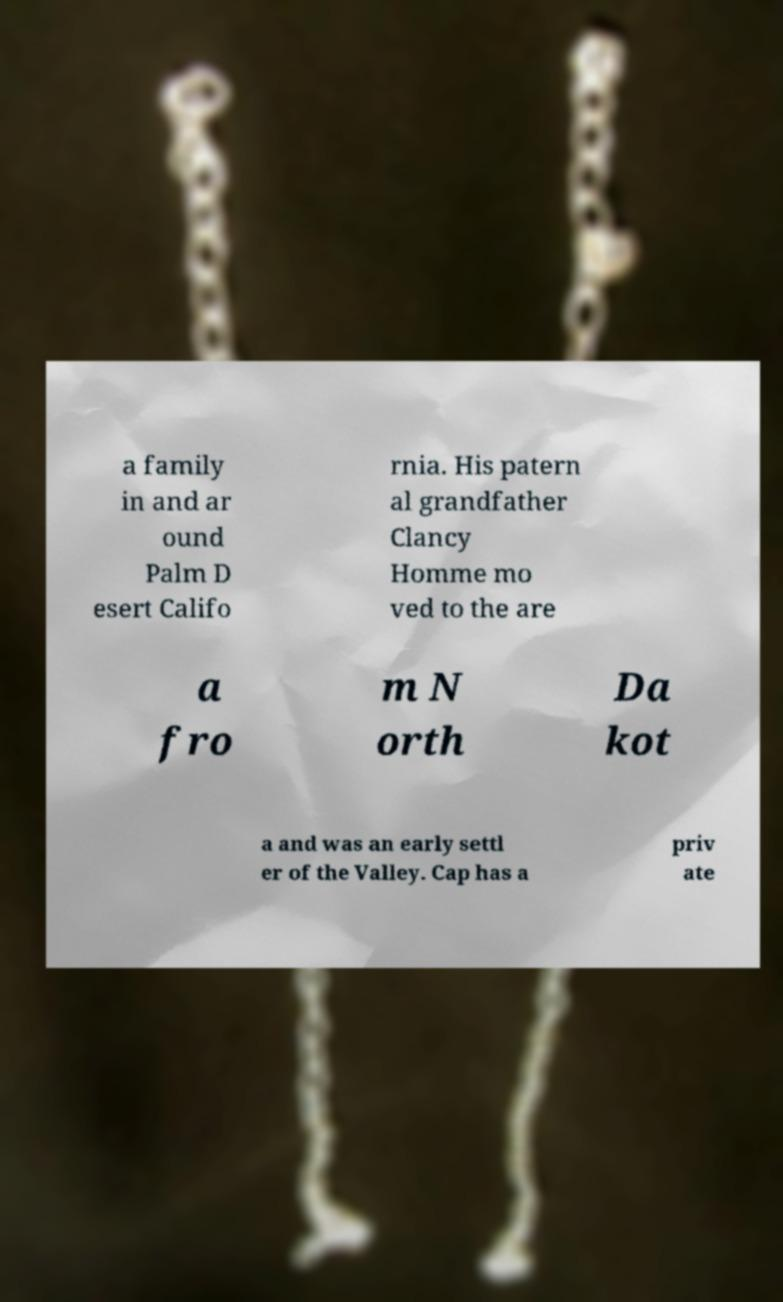There's text embedded in this image that I need extracted. Can you transcribe it verbatim? a family in and ar ound Palm D esert Califo rnia. His patern al grandfather Clancy Homme mo ved to the are a fro m N orth Da kot a and was an early settl er of the Valley. Cap has a priv ate 